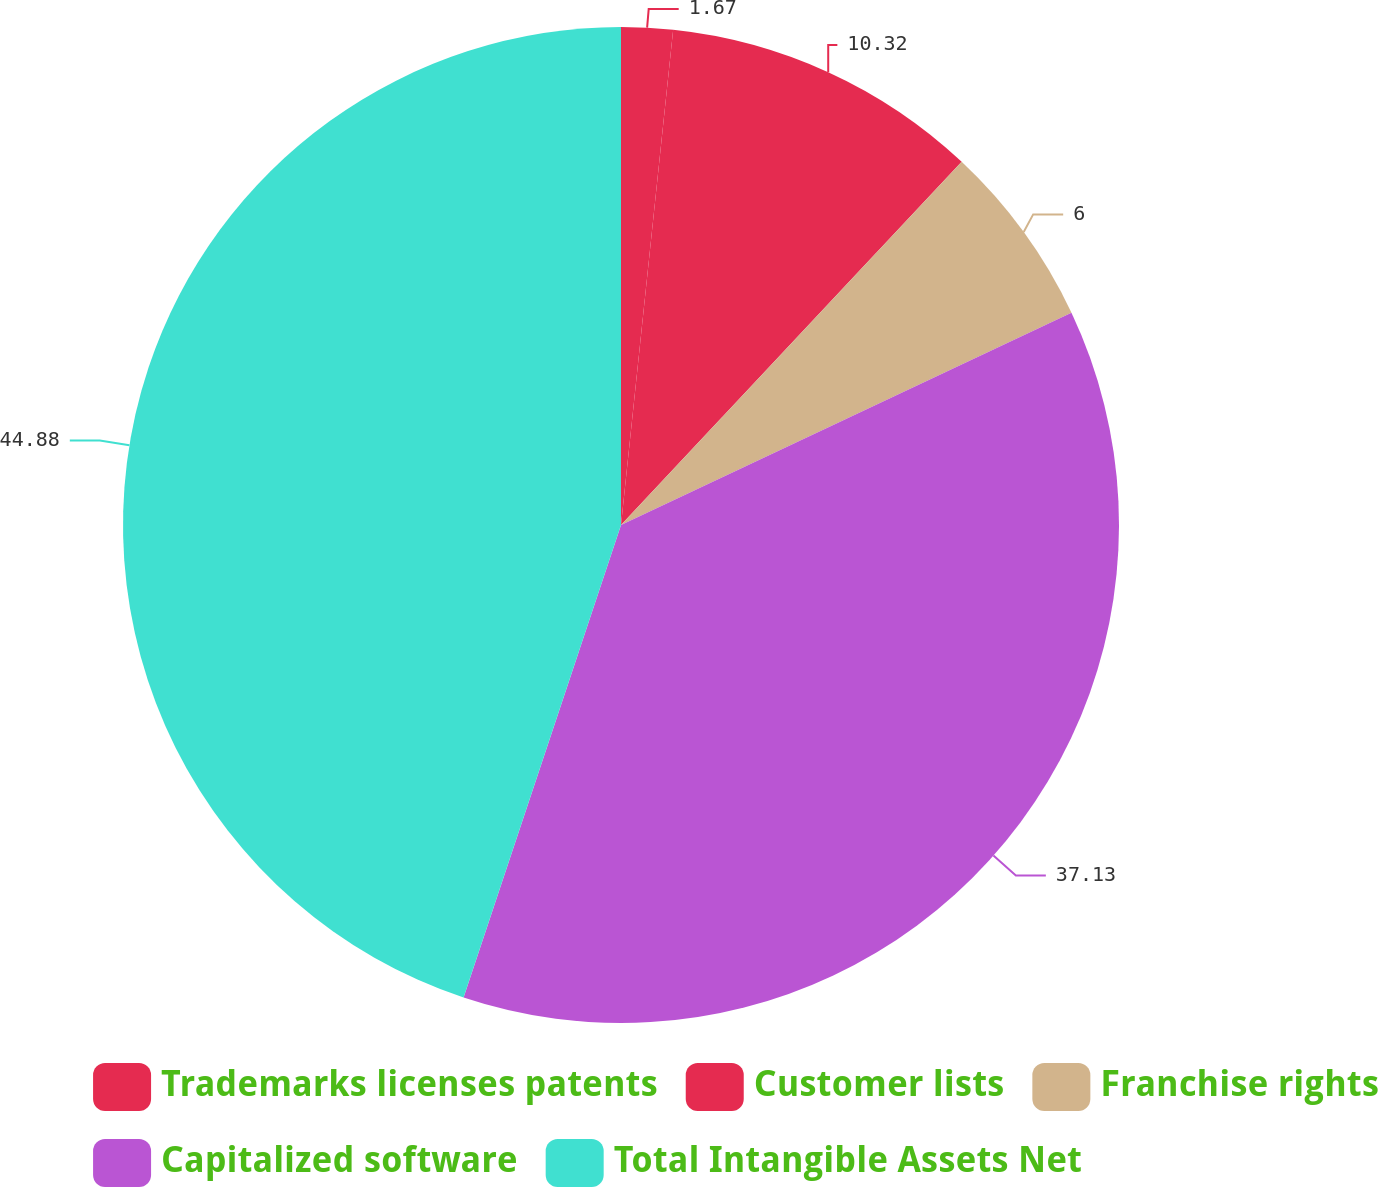<chart> <loc_0><loc_0><loc_500><loc_500><pie_chart><fcel>Trademarks licenses patents<fcel>Customer lists<fcel>Franchise rights<fcel>Capitalized software<fcel>Total Intangible Assets Net<nl><fcel>1.67%<fcel>10.32%<fcel>6.0%<fcel>37.13%<fcel>44.88%<nl></chart> 